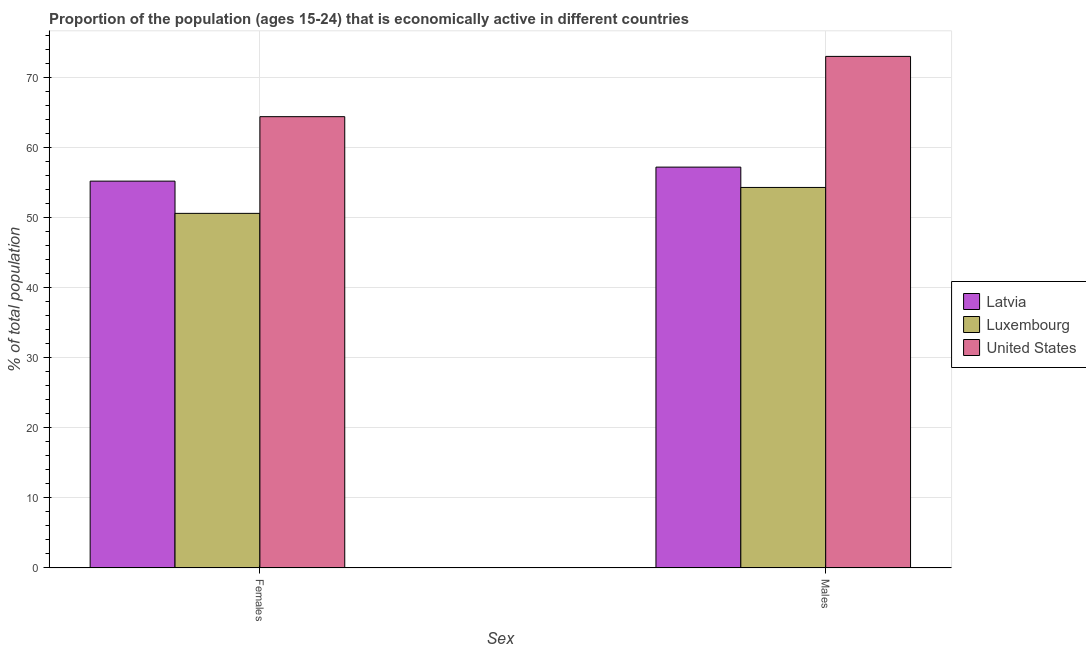How many different coloured bars are there?
Keep it short and to the point. 3. Are the number of bars per tick equal to the number of legend labels?
Provide a short and direct response. Yes. How many bars are there on the 2nd tick from the left?
Offer a very short reply. 3. What is the label of the 1st group of bars from the left?
Offer a very short reply. Females. What is the percentage of economically active female population in United States?
Give a very brief answer. 64.4. Across all countries, what is the maximum percentage of economically active female population?
Your answer should be compact. 64.4. Across all countries, what is the minimum percentage of economically active female population?
Provide a succinct answer. 50.6. In which country was the percentage of economically active male population minimum?
Your answer should be compact. Luxembourg. What is the total percentage of economically active female population in the graph?
Offer a very short reply. 170.2. What is the difference between the percentage of economically active male population in Latvia and that in Luxembourg?
Your response must be concise. 2.9. What is the difference between the percentage of economically active male population in Latvia and the percentage of economically active female population in Luxembourg?
Make the answer very short. 6.6. What is the average percentage of economically active female population per country?
Your answer should be very brief. 56.73. What is the difference between the percentage of economically active female population and percentage of economically active male population in Luxembourg?
Your response must be concise. -3.7. In how many countries, is the percentage of economically active male population greater than 38 %?
Offer a terse response. 3. What is the ratio of the percentage of economically active male population in Latvia to that in United States?
Keep it short and to the point. 0.78. In how many countries, is the percentage of economically active female population greater than the average percentage of economically active female population taken over all countries?
Your answer should be compact. 1. What does the 3rd bar from the left in Males represents?
Ensure brevity in your answer.  United States. Are all the bars in the graph horizontal?
Your answer should be compact. No. Are the values on the major ticks of Y-axis written in scientific E-notation?
Offer a very short reply. No. What is the title of the graph?
Make the answer very short. Proportion of the population (ages 15-24) that is economically active in different countries. What is the label or title of the X-axis?
Keep it short and to the point. Sex. What is the label or title of the Y-axis?
Your answer should be compact. % of total population. What is the % of total population in Latvia in Females?
Your answer should be compact. 55.2. What is the % of total population of Luxembourg in Females?
Your response must be concise. 50.6. What is the % of total population in United States in Females?
Offer a terse response. 64.4. What is the % of total population of Latvia in Males?
Offer a very short reply. 57.2. What is the % of total population in Luxembourg in Males?
Keep it short and to the point. 54.3. Across all Sex, what is the maximum % of total population in Latvia?
Make the answer very short. 57.2. Across all Sex, what is the maximum % of total population in Luxembourg?
Your answer should be compact. 54.3. Across all Sex, what is the minimum % of total population of Latvia?
Ensure brevity in your answer.  55.2. Across all Sex, what is the minimum % of total population in Luxembourg?
Your answer should be compact. 50.6. Across all Sex, what is the minimum % of total population of United States?
Provide a short and direct response. 64.4. What is the total % of total population in Latvia in the graph?
Offer a terse response. 112.4. What is the total % of total population of Luxembourg in the graph?
Offer a very short reply. 104.9. What is the total % of total population in United States in the graph?
Provide a short and direct response. 137.4. What is the difference between the % of total population in Latvia in Females and that in Males?
Your response must be concise. -2. What is the difference between the % of total population of United States in Females and that in Males?
Your answer should be very brief. -8.6. What is the difference between the % of total population in Latvia in Females and the % of total population in United States in Males?
Provide a short and direct response. -17.8. What is the difference between the % of total population in Luxembourg in Females and the % of total population in United States in Males?
Your response must be concise. -22.4. What is the average % of total population of Latvia per Sex?
Your response must be concise. 56.2. What is the average % of total population in Luxembourg per Sex?
Your answer should be very brief. 52.45. What is the average % of total population of United States per Sex?
Keep it short and to the point. 68.7. What is the difference between the % of total population of Luxembourg and % of total population of United States in Females?
Keep it short and to the point. -13.8. What is the difference between the % of total population of Latvia and % of total population of United States in Males?
Your answer should be very brief. -15.8. What is the difference between the % of total population in Luxembourg and % of total population in United States in Males?
Make the answer very short. -18.7. What is the ratio of the % of total population of Latvia in Females to that in Males?
Your answer should be compact. 0.96. What is the ratio of the % of total population in Luxembourg in Females to that in Males?
Offer a very short reply. 0.93. What is the ratio of the % of total population of United States in Females to that in Males?
Your answer should be compact. 0.88. What is the difference between the highest and the second highest % of total population of Latvia?
Offer a very short reply. 2. What is the difference between the highest and the second highest % of total population of Luxembourg?
Make the answer very short. 3.7. What is the difference between the highest and the lowest % of total population in Latvia?
Ensure brevity in your answer.  2. What is the difference between the highest and the lowest % of total population of United States?
Ensure brevity in your answer.  8.6. 